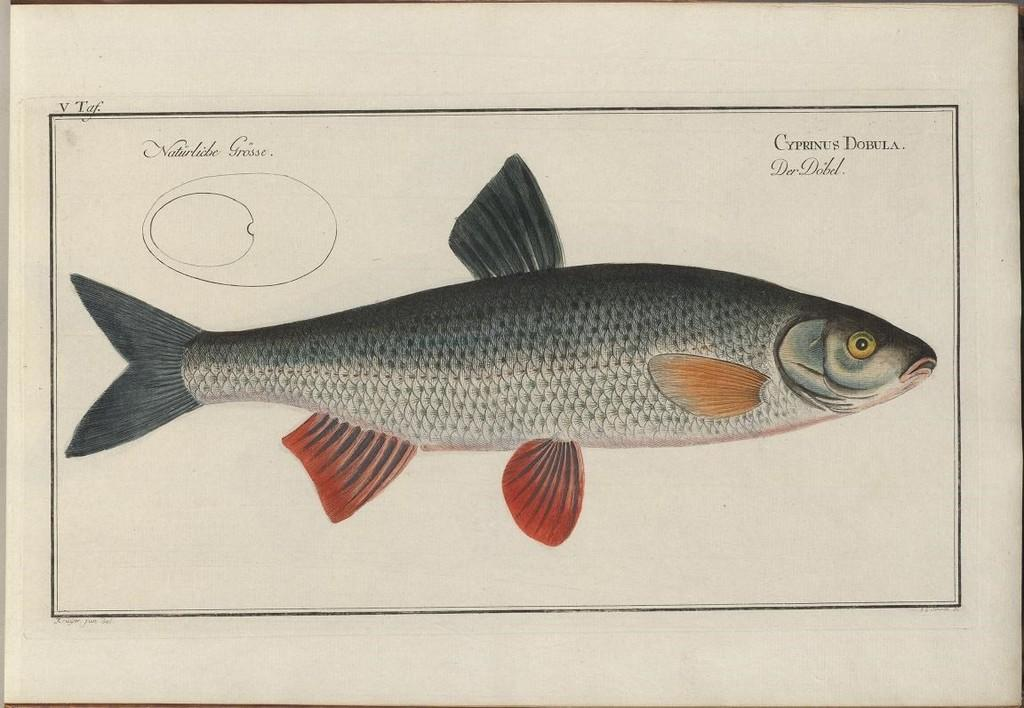What is depicted in the painting in the image? There is a painting of a fish in the image. What is the painting placed on? The painting is on a sheet. What feature does the sheet have? The sheet has a border. What else is present on the sheet besides the painting? There are texts and a drawing on the sheet. What is the background color of the sheet? The background color of the sheet is cream. What type of structure can be seen supporting the ice in the image? There is no ice or structure present in the image. 